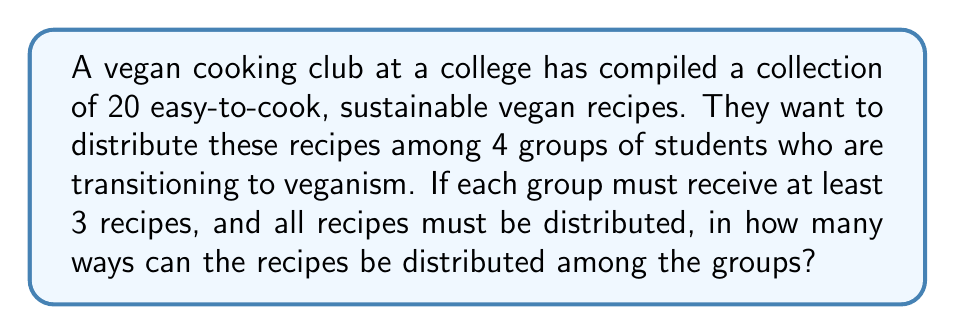Can you answer this question? Let's approach this step-by-step using the stars and bars method:

1) First, we need to distribute 20 recipes among 4 groups, with each group getting at least 3 recipes. We can start by giving each group 3 recipes:

   $3 + 3 + 3 + 3 = 12$ recipes

2) Now we have 8 recipes left to distribute freely ($20 - 12 = 8$).

3) This problem is equivalent to finding the number of ways to put 8 identical objects (remaining recipes) into 4 distinct boxes (student groups).

4) The stars and bars formula for this scenario is:

   $${n+k-1 \choose k-1}$$

   Where $n$ is the number of identical objects and $k$ is the number of distinct boxes.

5) In our case, $n = 8$ and $k = 4$. So we have:

   $${8+4-1 \choose 4-1} = {11 \choose 3}$$

6) We can calculate this as:

   $${11 \choose 3} = \frac{11!}{3!(11-3)!} = \frac{11!}{3!8!}$$

7) Expanding this:

   $$\frac{11 \times 10 \times 9 \times 8!}{(3 \times 2 \times 1) \times 8!} = \frac{990}{6} = 165$$

Therefore, there are 165 ways to distribute the recipes among the 4 groups.
Answer: 165 